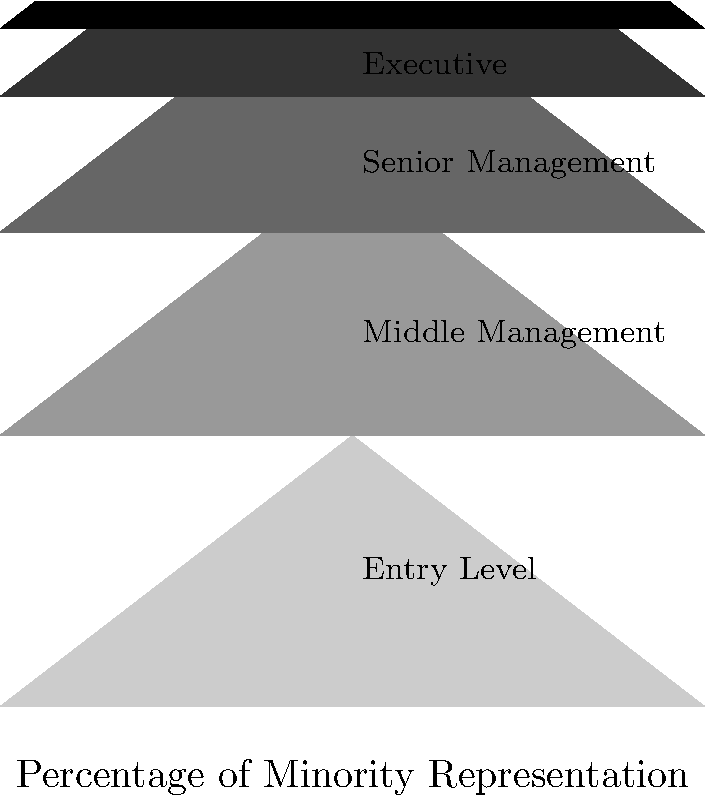Analyze the pyramid chart depicting minority representation across various organizational levels. Which level shows the most significant drop in minority representation compared to the level immediately below it, and what ethical implications does this have for organizational diversity and inclusion efforts? To answer this question, we need to analyze the pyramid chart step-by-step:

1. The chart shows five levels of an organization, from Entry Level to CEO, with the width of each level representing the percentage of minority representation.

2. Starting from the bottom:
   - Entry Level: 100% (baseline)
   - Middle Management: 75%
   - Senior Management: 50%
   - Executive: 25%
   - CEO: 10%

3. To find the most significant drop, we need to calculate the percentage decrease between each adjacent level:
   - Entry Level to Middle Management: (100% - 75%) / 100% = 25% decrease
   - Middle Management to Senior Management: (75% - 50%) / 75% = 33.3% decrease
   - Senior Management to Executive: (50% - 25%) / 50% = 50% decrease
   - Executive to CEO: (25% - 10%) / 25% = 60% decrease

4. The most significant drop is between the Executive level and CEO level, with a 60% decrease.

5. Ethical implications of this drop:
   a. Lack of diversity at the highest level of leadership
   b. Potential bias in promotion and selection processes
   c. Limited representation of minority perspectives in top-level decision-making
   d. Reinforcement of existing power structures and inequalities
   e. Missed opportunities for diverse viewpoints and innovative problem-solving
   f. Potential negative impact on organizational culture and employee morale
   g. Inconsistency with ethical principles of equality and fairness

6. From an ethical standpoint, this significant drop raises questions about:
   - The organization's commitment to diversity and inclusion
   - The effectiveness of existing diversity initiatives
   - The presence of systemic barriers or unconscious biases in the promotion process
   - The need for targeted interventions to address the lack of minority representation at the CEO level
Answer: Executive to CEO (60% drop); implications include lack of diverse perspectives in top leadership, potential bias in promotion processes, and inconsistency with ethical principles of equality and fairness. 